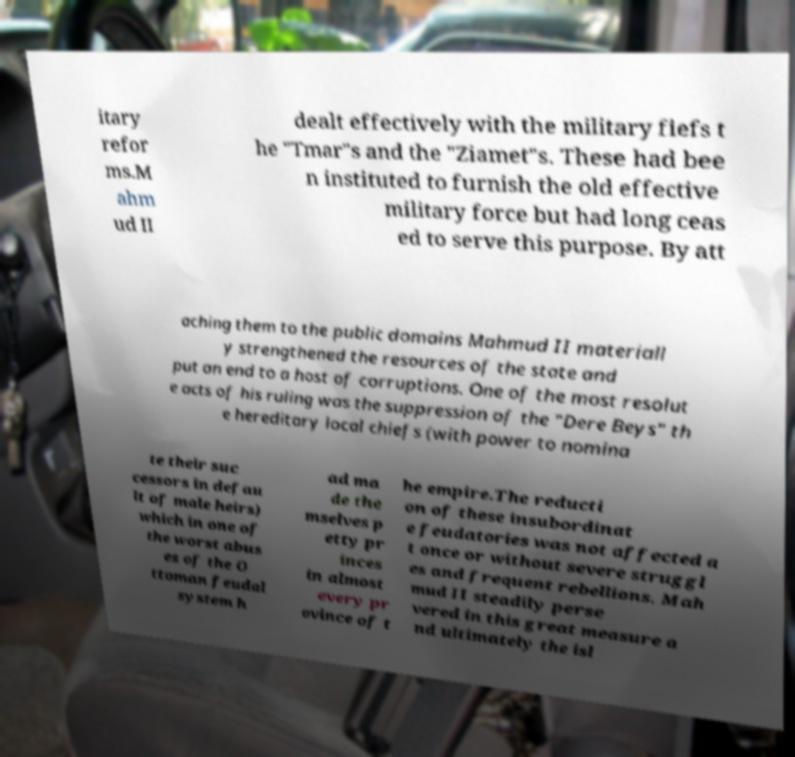Please identify and transcribe the text found in this image. itary refor ms.M ahm ud II dealt effectively with the military fiefs t he "Tmar"s and the "Ziamet"s. These had bee n instituted to furnish the old effective military force but had long ceas ed to serve this purpose. By att aching them to the public domains Mahmud II materiall y strengthened the resources of the state and put an end to a host of corruptions. One of the most resolut e acts of his ruling was the suppression of the "Dere Beys" th e hereditary local chiefs (with power to nomina te their suc cessors in defau lt of male heirs) which in one of the worst abus es of the O ttoman feudal system h ad ma de the mselves p etty pr inces in almost every pr ovince of t he empire.The reducti on of these insubordinat e feudatories was not affected a t once or without severe struggl es and frequent rebellions. Mah mud II steadily perse vered in this great measure a nd ultimately the isl 